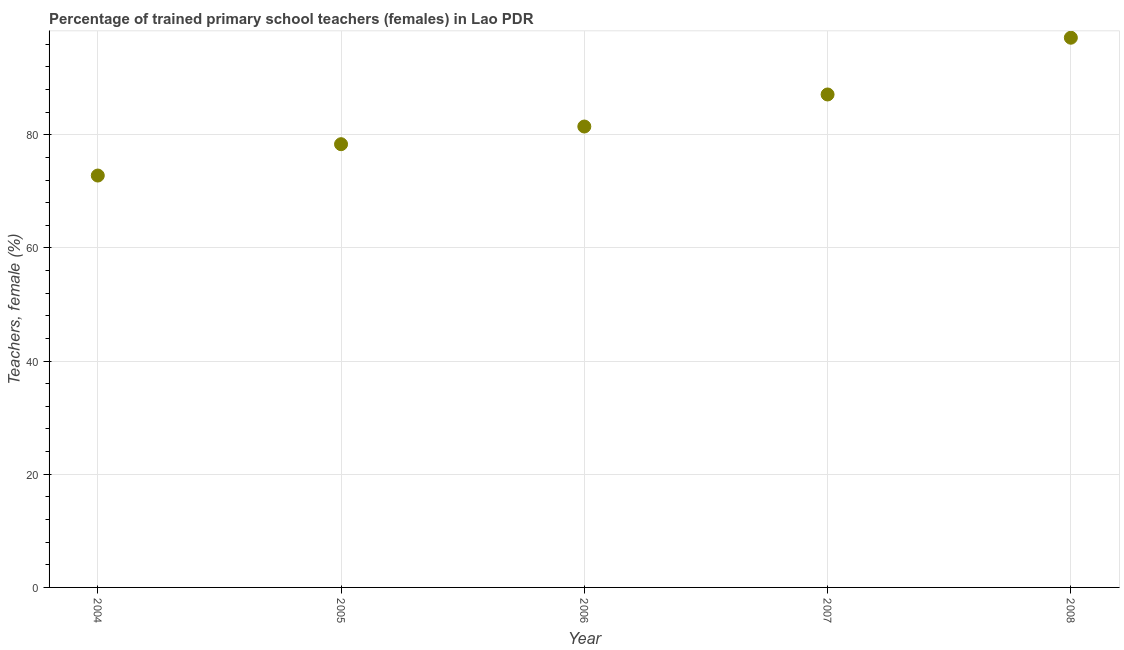What is the percentage of trained female teachers in 2005?
Your response must be concise. 78.34. Across all years, what is the maximum percentage of trained female teachers?
Offer a very short reply. 97.15. Across all years, what is the minimum percentage of trained female teachers?
Keep it short and to the point. 72.79. What is the sum of the percentage of trained female teachers?
Make the answer very short. 416.86. What is the difference between the percentage of trained female teachers in 2004 and 2007?
Your response must be concise. -14.33. What is the average percentage of trained female teachers per year?
Make the answer very short. 83.37. What is the median percentage of trained female teachers?
Provide a succinct answer. 81.46. In how many years, is the percentage of trained female teachers greater than 4 %?
Ensure brevity in your answer.  5. Do a majority of the years between 2008 and 2005 (inclusive) have percentage of trained female teachers greater than 92 %?
Ensure brevity in your answer.  Yes. What is the ratio of the percentage of trained female teachers in 2005 to that in 2006?
Provide a succinct answer. 0.96. Is the difference between the percentage of trained female teachers in 2007 and 2008 greater than the difference between any two years?
Offer a very short reply. No. What is the difference between the highest and the second highest percentage of trained female teachers?
Your answer should be compact. 10.03. What is the difference between the highest and the lowest percentage of trained female teachers?
Your answer should be compact. 24.36. What is the difference between two consecutive major ticks on the Y-axis?
Make the answer very short. 20. Are the values on the major ticks of Y-axis written in scientific E-notation?
Offer a very short reply. No. Does the graph contain grids?
Make the answer very short. Yes. What is the title of the graph?
Your response must be concise. Percentage of trained primary school teachers (females) in Lao PDR. What is the label or title of the Y-axis?
Provide a short and direct response. Teachers, female (%). What is the Teachers, female (%) in 2004?
Give a very brief answer. 72.79. What is the Teachers, female (%) in 2005?
Offer a very short reply. 78.34. What is the Teachers, female (%) in 2006?
Keep it short and to the point. 81.46. What is the Teachers, female (%) in 2007?
Your answer should be compact. 87.12. What is the Teachers, female (%) in 2008?
Your response must be concise. 97.15. What is the difference between the Teachers, female (%) in 2004 and 2005?
Ensure brevity in your answer.  -5.54. What is the difference between the Teachers, female (%) in 2004 and 2006?
Your answer should be very brief. -8.66. What is the difference between the Teachers, female (%) in 2004 and 2007?
Your answer should be compact. -14.33. What is the difference between the Teachers, female (%) in 2004 and 2008?
Your answer should be very brief. -24.36. What is the difference between the Teachers, female (%) in 2005 and 2006?
Your response must be concise. -3.12. What is the difference between the Teachers, female (%) in 2005 and 2007?
Provide a short and direct response. -8.79. What is the difference between the Teachers, female (%) in 2005 and 2008?
Make the answer very short. -18.82. What is the difference between the Teachers, female (%) in 2006 and 2007?
Offer a terse response. -5.66. What is the difference between the Teachers, female (%) in 2006 and 2008?
Provide a short and direct response. -15.69. What is the difference between the Teachers, female (%) in 2007 and 2008?
Give a very brief answer. -10.03. What is the ratio of the Teachers, female (%) in 2004 to that in 2005?
Keep it short and to the point. 0.93. What is the ratio of the Teachers, female (%) in 2004 to that in 2006?
Offer a very short reply. 0.89. What is the ratio of the Teachers, female (%) in 2004 to that in 2007?
Ensure brevity in your answer.  0.84. What is the ratio of the Teachers, female (%) in 2004 to that in 2008?
Make the answer very short. 0.75. What is the ratio of the Teachers, female (%) in 2005 to that in 2006?
Your answer should be very brief. 0.96. What is the ratio of the Teachers, female (%) in 2005 to that in 2007?
Your response must be concise. 0.9. What is the ratio of the Teachers, female (%) in 2005 to that in 2008?
Provide a succinct answer. 0.81. What is the ratio of the Teachers, female (%) in 2006 to that in 2007?
Your answer should be very brief. 0.94. What is the ratio of the Teachers, female (%) in 2006 to that in 2008?
Provide a short and direct response. 0.84. What is the ratio of the Teachers, female (%) in 2007 to that in 2008?
Your answer should be very brief. 0.9. 